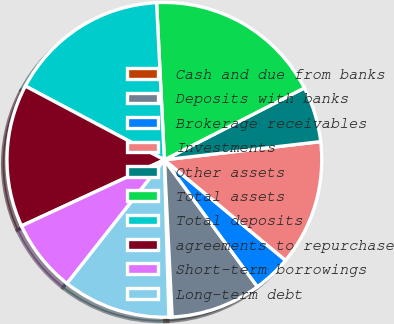Convert chart. <chart><loc_0><loc_0><loc_500><loc_500><pie_chart><fcel>Cash and due from banks<fcel>Deposits with banks<fcel>Brokerage receivables<fcel>Investments<fcel>Other assets<fcel>Total assets<fcel>Total deposits<fcel>agreements to repurchase<fcel>Short-term borrowings<fcel>Long-term debt<nl><fcel>0.33%<fcel>9.28%<fcel>3.91%<fcel>12.87%<fcel>5.7%<fcel>18.24%<fcel>16.45%<fcel>14.66%<fcel>7.49%<fcel>11.07%<nl></chart> 